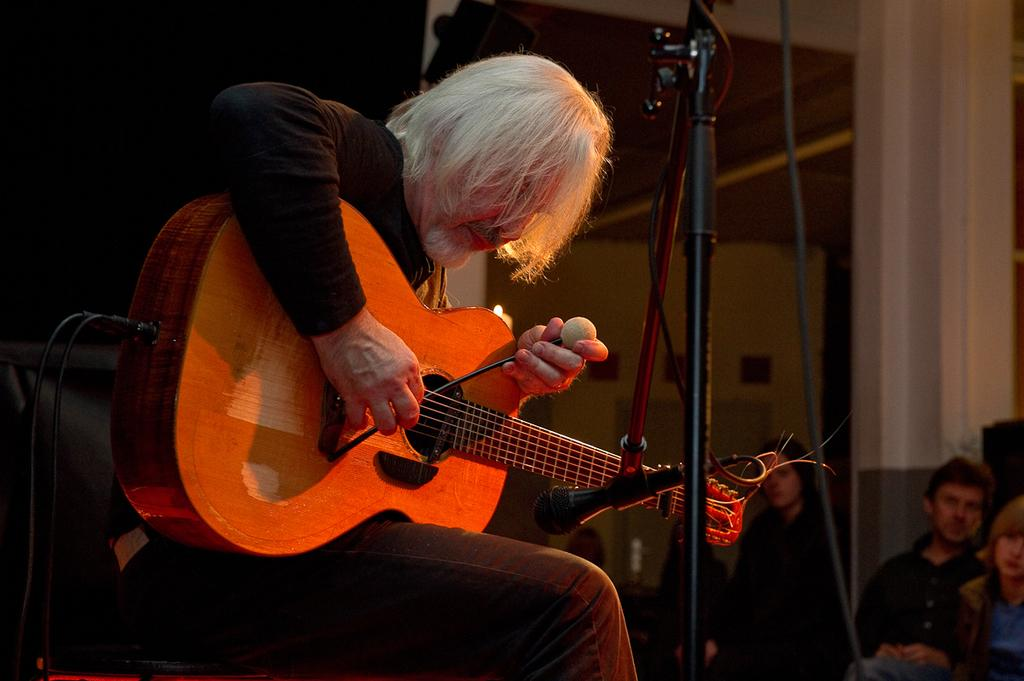What is the man in the image doing? The man is sitting in the image and holding a guitar in his hand. What is in front of the man? There is a stand in front of the man. Who else is present in the image? There is a group of people sitting in the image. What type of bit is the man using to play the guitar in the image? There is no bit present in the image, as the man is playing a guitar, not a horse. 